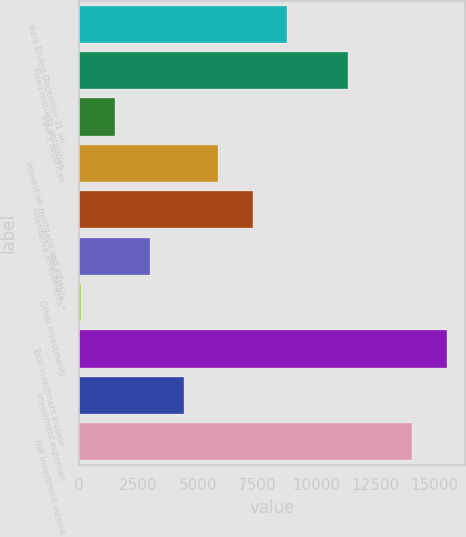Convert chart. <chart><loc_0><loc_0><loc_500><loc_500><bar_chart><fcel>Years Ended December 31 (in<fcel>Fixed maturity securities<fcel>Equity securities<fcel>Interest on mortgage and other<fcel>Alternative investments^<fcel>Real estate<fcel>Other investments<fcel>Total investment income<fcel>Investment expenses<fcel>Net investment income<nl><fcel>8779<fcel>11332<fcel>1526.5<fcel>5878<fcel>7328.5<fcel>2977<fcel>76<fcel>15503.5<fcel>4427.5<fcel>14053<nl></chart> 